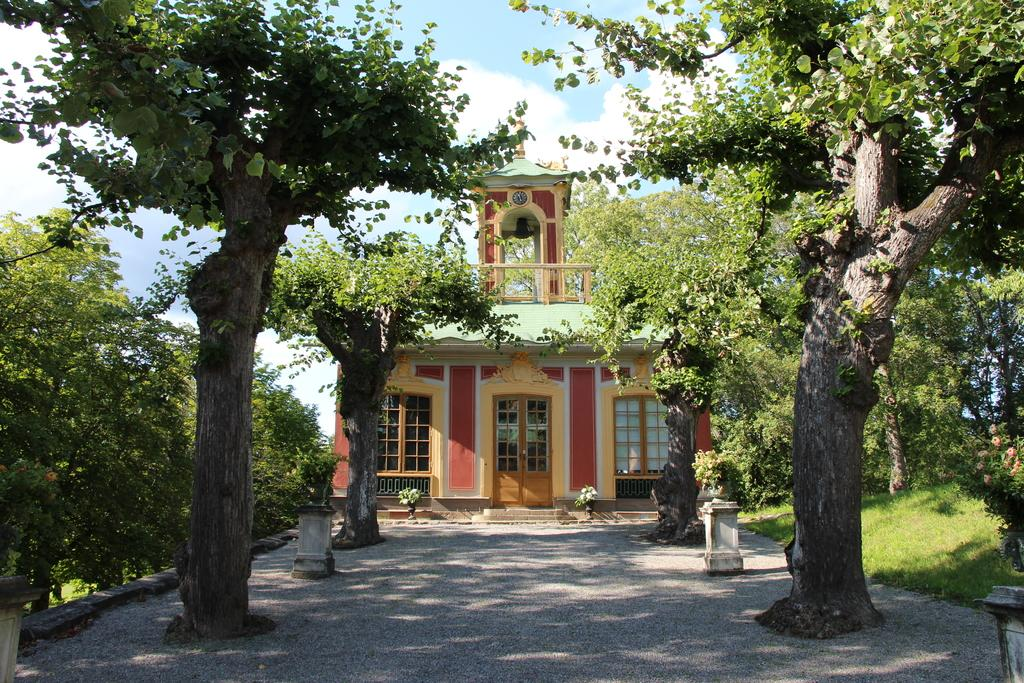What type of vegetation can be seen in the image? There are trees and plants in the image. What is on the ground in the image? There is grass on the ground in the image. What type of structure is present in the image? There is a building with doors and windows in the image. What is visible at the top of the image? The sky is visible at the top of the image. Can you see a snake slithering through the grass in the image? There is no snake present in the image; it only features trees, plants, grass, a building, and the sky. Is there a person walking through the grass in the image? There is no person present in the image; it only features trees, plants, grass, a building, and the sky. 